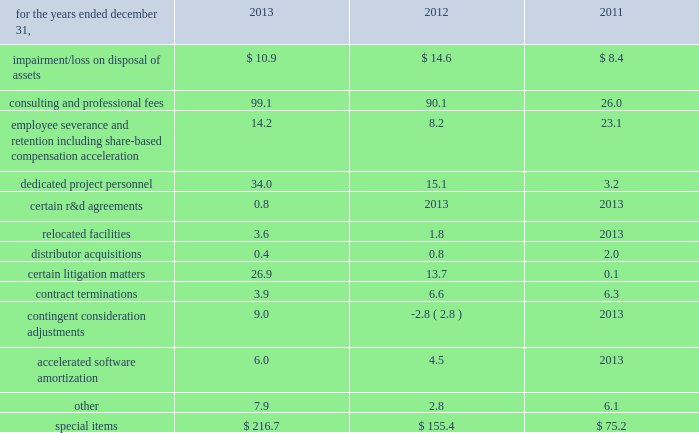Zimmer holdings , inc .
2013 form 10-k annual report notes to consolidated financial statements ( continued ) fees paid to collaborative partners .
Where contingent milestone payments are due to third parties under research and development arrangements , the milestone payment obligations are expensed when the milestone results are achieved .
Litigation 2013 we record a liability for contingent losses , including future legal costs , settlements and judgments , when we consider it is probable that a liability has been incurred and the amount of the loss can be reasonably estimated .
Special items 2013 we recognize expenses resulting directly from our business combinations , employee termination benefits , certain r&d agreements , certain contract terminations , consulting and professional fees and asset impairment or loss on disposal charges connected with global restructuring , operational and quality excellence initiatives , and other items as 201cspecial items 201d in our consolidated statement of earnings .
201cspecial items 201d included ( in millions ) : .
Impairment/ loss on disposal of assets relates to impairment of intangible assets that were acquired in business combinations or impairment of or a loss on the disposal of other assets .
Consulting and professional fees relate to third-party consulting , professional fees and contract labor related to our quality and operational excellence initiatives , third-party consulting fees related to certain information system implementations , third-party integration consulting performed in a variety of areas such as tax , compliance , logistics and human resources for our business combinations , third-party fees related to severance and termination benefits matters and legal fees related to certain product liability matters .
Our quality and operational excellence initiatives are company- wide and include improvements in quality , distribution , sourcing , manufacturing and information technology , among other areas .
In 2013 , 2012 and 2011 , we eliminated positions as we reduced management layers , restructured certain areas , announced closures of certain facilities , and commenced initiatives to focus on business opportunities that best support our strategic priorities .
In 2013 , 2012 and 2011 , approximately 170 , 400 and 500 positions , respectively , from across the globe were affected by these actions .
As a result of these changes in our work force and headcount reductions in connection with acquisitions , we incurred expenses related to severance benefits , redundant salaries as we worked through transition periods , share-based compensation acceleration and other employee termination-related costs .
The majority of these termination benefits were provided in accordance with our existing or local government policies and are considered ongoing benefits .
These costs were accrued when they became probable and estimable and were recorded as part of other current liabilities .
The majority of these costs were paid during the year they were incurred .
Dedicated project personnel expenses include the salary , benefits , travel expenses and other costs directly associated with employees who are 100 percent dedicated to our operational and quality excellence initiatives or integration of acquired businesses .
Certain r&d agreements relate to agreements with upfront payments to obtain intellectual property to be used in r&d projects that have no alternative future use in other projects .
Relocated facilities expenses are the moving costs and the lease expenses incurred during the relocation period in connection with relocating certain facilities .
Over the past few years we have acquired a number of u.s .
And foreign-based distributors .
We have incurred various costs related to the consummation and integration of those businesses .
Certain litigation matters relate to costs and adjustments recognized during the year for the estimated or actual settlement of various legal matters , including royalty disputes , patent litigation matters , commercial litigation matters and matters arising from our acquisitions of certain competitive distributorships in prior years .
Contract termination costs relate to terminated agreements in connection with the integration of acquired companies and changes to our distribution model as part of business restructuring and operational excellence initiatives .
The terminated contracts primarily relate to sales agents and distribution agreements .
Contingent consideration adjustments represent the changes in the fair value of contingent consideration obligations to be paid to the prior owners of acquired businesses .
Accelerated software amortization is the incremental amortization resulting from a reduction in the estimated life of certain software .
In 2012 , we approved a plan to replace certain software .
As a result , the estimated economic useful life of the existing software was decreased to represent the period of time expected to implement replacement software .
As a result , the amortization from the shortened life of this software is substantially higher than the previous amortization being recognized .
Cash and cash equivalents 2013 we consider all highly liquid investments with an original maturity of three months or less to be cash equivalents .
The carrying amounts reported in the balance sheet for cash and cash equivalents are valued at cost , which approximates their fair value. .
What is the percent change in accelerated software amortization from 2012 to 2013? 
Computations: ((6.0 - 4.5) / 4.5)
Answer: 0.33333. 